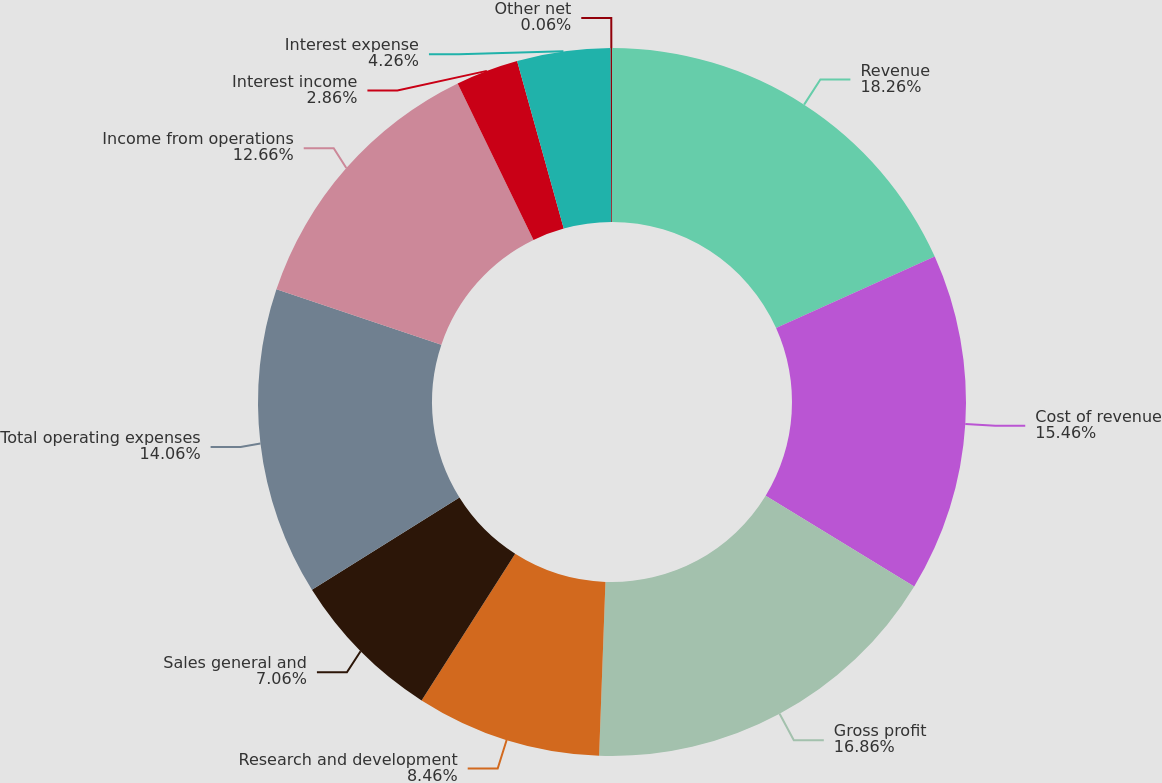Convert chart. <chart><loc_0><loc_0><loc_500><loc_500><pie_chart><fcel>Revenue<fcel>Cost of revenue<fcel>Gross profit<fcel>Research and development<fcel>Sales general and<fcel>Total operating expenses<fcel>Income from operations<fcel>Interest income<fcel>Interest expense<fcel>Other net<nl><fcel>18.26%<fcel>15.46%<fcel>16.86%<fcel>8.46%<fcel>7.06%<fcel>14.06%<fcel>12.66%<fcel>2.86%<fcel>4.26%<fcel>0.06%<nl></chart> 